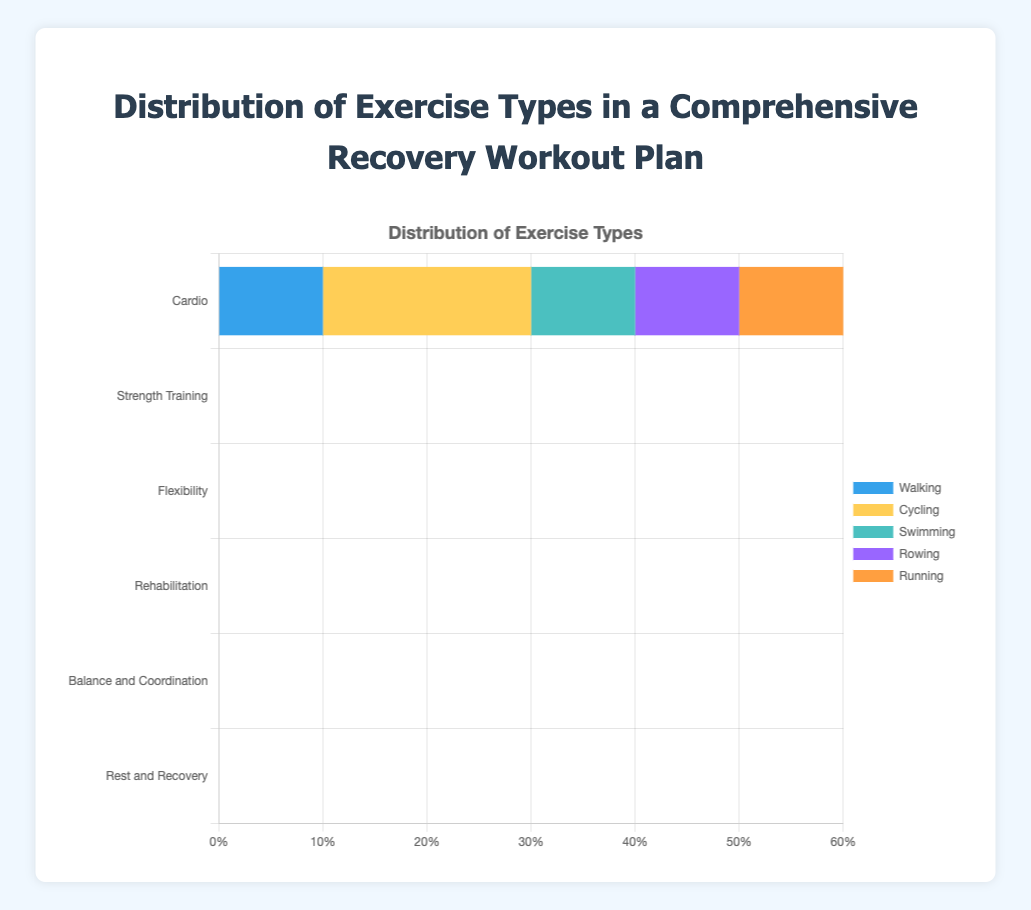What proportion of the 'Strength Training' segment is occupied by 'Bodyweight Exercises'? The 'Bodyweight Exercises' part in the 'Strength Training' category is represented as 0.2 out of a total of 0.5 (0.2 + 0.15 + 0.1 + 0.05). The proportion is calculated as (0.2 / 0.5) * 100%.
Answer: 40% Which exercise type contributes most to the 'Rehabilitation' segment? By examining the 'Rehabilitation' segment, the percentages are 0.4 (Physical Therapy), 0.2 (Massage), 0.2 (Hydrotherapy), and 0.2 (Electrotherapy). 'Physical Therapy' has the highest value.
Answer: Physical Therapy Add the contributions of 'Sleep' and 'Meditation' in the 'Rest and Recovery' category. 'Sleep' contributes 0.5 and 'Meditation' contributes 0.2 in the 'Rest and Recovery' category. Adding them together: 0.5 + 0.2 = 0.7.
Answer: 0.7 Which type of exercise has the highest individual proportion across all categories? By examining all the segments, 'Sleep' in the 'Rest and Recovery' category has the highest individual proportion at 0.5.
Answer: Sleep How do 'Cycling' in 'Cardio' and 'Bodyweight Exercises' in 'Strength Training' compare in their respective categories? 'Cycling' in 'Cardio' contributes 0.2 and 'Bodyweight Exercises' in 'Strength Training' also contributes 0.2. Both have equal contributions within their respective categories.
Answer: Equal What is the total proportion of 'Stretching' activities in the 'Flexibility' segment? In 'Flexibility', the activities related to stretching are 'Static Stretching' (0.2) and 'Dynamic Stretching' (0.1). Summing them: 0.2 + 0.1 = 0.3.
Answer: 0.3 Among 'Balance and Coordination' exercises, which one has the smallest proportion? The 'Balance Board', 'Stability Ball', 'Coordination Drills', and 'Tai Chi' have proportions of 0.15, 0.25, 0.15, and 0.15 respectively. The smallest is 0.15, shared by 'Balance Board', 'Coordination Drills', and 'Tai Chi'.
Answer: Balance Board, Coordination Drills, Tai Chi Compare the proportion of 'Yoga' in the 'Flexibility' category to 'Nutrition Planning' in the 'Rest and Recovery' category. 'Yoga' in 'Flexibility' has a proportion of 0.2, and 'Nutrition Planning' in 'Rest and Recovery' has a proportion of 0.3. 'Nutrition Planning' has a higher proportion.
Answer: Nutrition Planning What is the combined proportion of 'Cycling', 'Swimming', and 'Rowing' in the 'Cardio' segment? In the 'Cardio' segment, 'Cycling' is 0.2, 'Swimming' is 0.1, and 'Rowing' is 0.1. Summing them: 0.2 + 0.1 + 0.1 = 0.4.
Answer: 0.4 